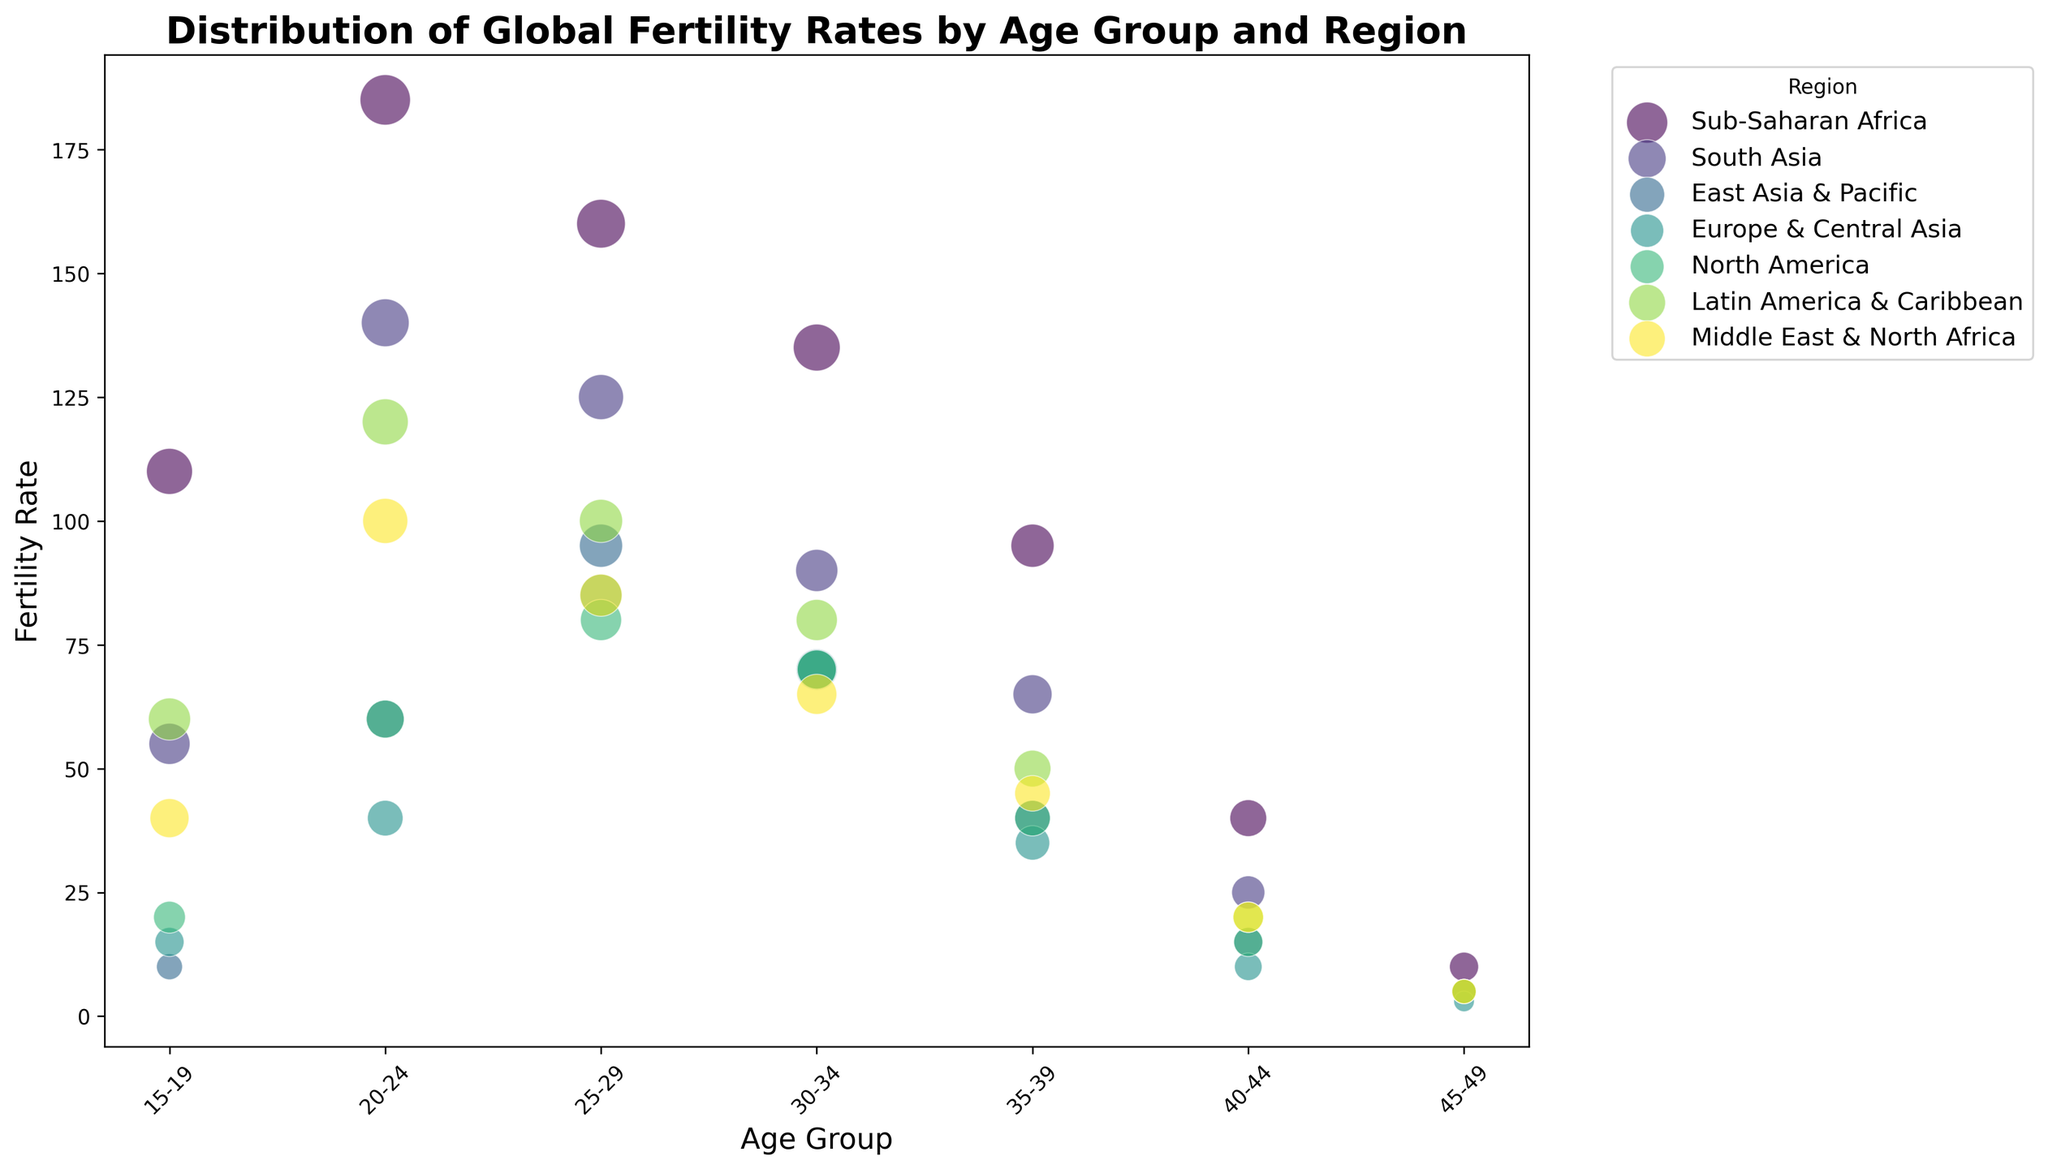Which region has the highest fertility rate in the 25-29 age group? Look at the bubble chart and locate the 25-29 age group. Among the regions, identify the highest fertility rate value. Sub-Saharan Africa has the highest fertility rate of 160 in this age group.
Answer: Sub-Saharan Africa Which region shows the highest fertility rate for the age group 15-19? Find the bubble that represents the age group 15-19 and compare the fertility rates of all regions. Sub-Saharan Africa has the highest fertility rate of 110 in this age group.
Answer: Sub-Saharan Africa What is the total fertility rate for North America from ages 20-29? Locate the bubbles for North America in the age groups of 20-24 and 25-29. The fertility rates are 60 and 80 respectively. Sum these values to get the total fertility rate: 60 + 80.
Answer: 140 Compare the fertility rates of East Asia & Pacific and Europe & Central Asia in the age group 20-24. Which one is higher? Locate the 20-24 age group for both regions and compare their fertility rates. East Asia & Pacific has a fertility rate of 60, while Europe & Central Asia has a rate of 40.
Answer: East Asia & Pacific What is the difference in the bubble size between Sub-Saharan Africa and South Asia for the age group 15-19? Locate the bubbles for Sub-Saharan Africa and South Asia in the 15-19 age group. Sub-Saharan Africa has a bubble size of 25, and South Asia has a bubble size of 20. The difference is 25 - 20.
Answer: 5 Which age group in Sub-Saharan Africa shows the smallest fertility rate? Identify all bubbles representing Sub-Saharan Africa and find the one with the smallest fertility rate. The 45-49 age group has the smallest rate of 10.
Answer: 45-49 How does the fertility rate in the 30-34 age group for East Asia & Pacific compare to South Asia? Locate the 30-34 age group for both regions and compare their fertility rates. East Asia & Pacific has a rate of 70, while South Asia has a rate of 90.
Answer: South Asia is higher Which region has the smallest bubble size for the age group 35-39? Locate the bubbles for the 35-39 age group across all regions and compare their sizes. Europe & Central Asia has the smallest bubble size of 14.
Answer: Europe & Central Asia What is the average fertility rate for the 40-44 age group across all regions? Identify the fertility rates for the 40-44 age group across all regions: 40, 25, 15, 10, 15, 20, 20. Sum these values: 40 + 25 + 15 + 10 + 15 + 20 + 20 = 145. Count the number of values (7) and divide the sum by this count: 145 / 7.
Answer: 20.71 